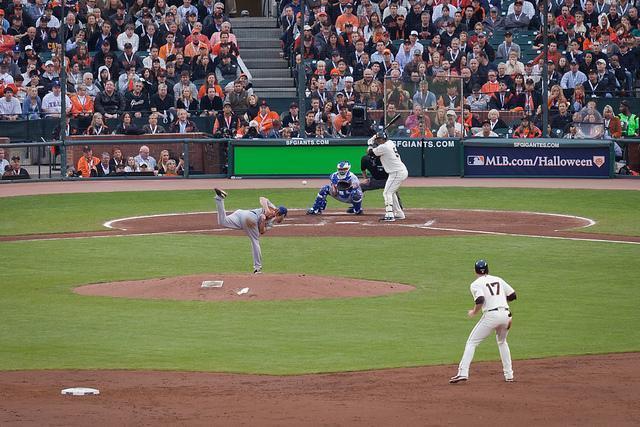What is the man on one leg doing?
Select the accurate answer and provide explanation: 'Answer: answer
Rationale: rationale.'
Options: Singing, hopping, pitching, hiding. Answer: pitching.
Rationale: The man is in a baseball uniform and standing on the pitcher's mound. 